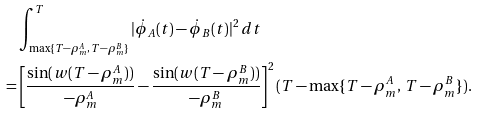<formula> <loc_0><loc_0><loc_500><loc_500>& \int _ { \max \{ T - \rho _ { m } ^ { A } , \, T - \rho _ { m } ^ { B } \} } ^ { T } | \dot { \phi } _ { A } ( t ) - \dot { \phi } _ { B } ( t ) | ^ { 2 } \, d t \\ = & \left [ \frac { \sin ( w ( T - \rho _ { m } ^ { A } ) ) } { - \rho _ { m } ^ { A } } - \frac { \sin ( w ( T - \rho _ { m } ^ { B } ) ) } { - \rho _ { m } ^ { B } } \right ] ^ { 2 } ( T - \max \{ T - \rho _ { m } ^ { A } , \, T - \rho _ { m } ^ { B } \} ) .</formula> 